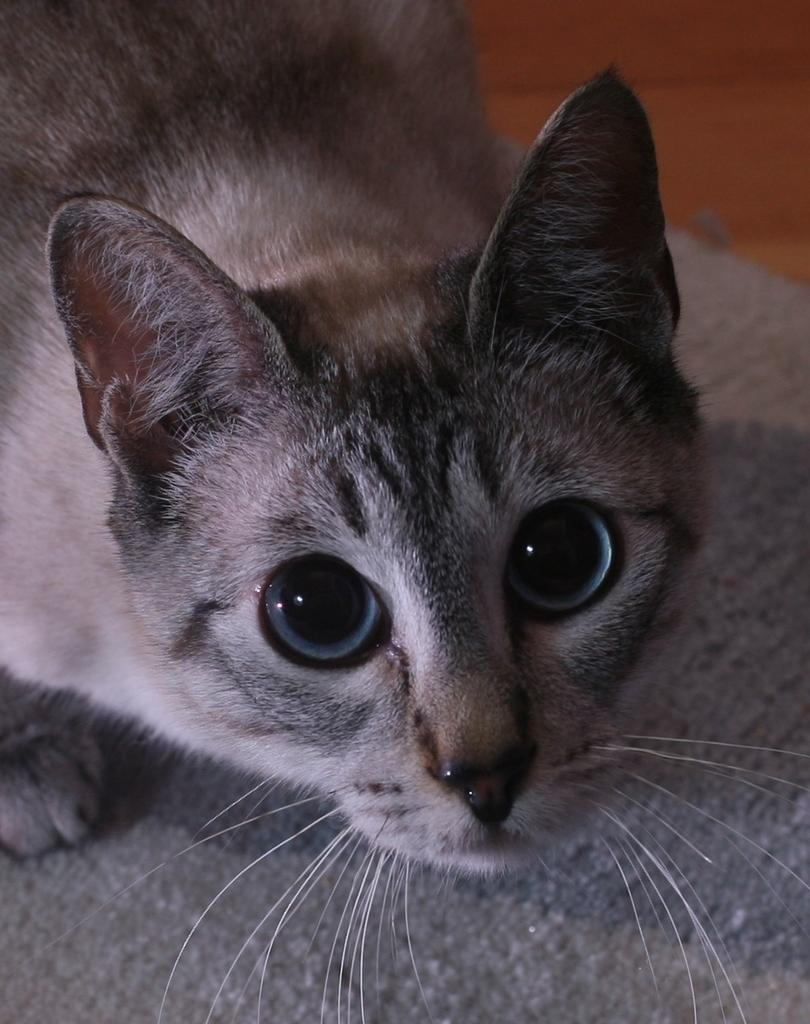What is the main subject in the center of the image? There is a cat in the center of the image. What is located at the bottom of the image? There is a floor mat placed on the floor at the bottom of the image. How does the cat feel about the mint in the image? There is no mint present in the image, so it is not possible to determine how the cat feels about it. 